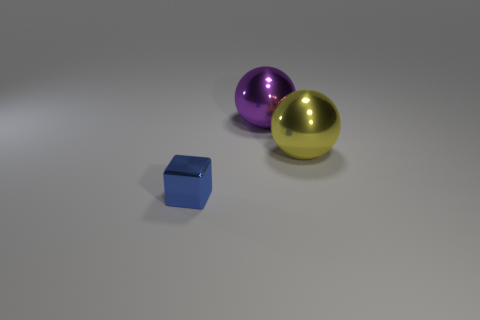Add 1 shiny cubes. How many objects exist? 4 Subtract all spheres. How many objects are left? 1 Subtract all purple balls. How many balls are left? 1 Subtract 2 balls. How many balls are left? 0 Subtract all purple cylinders. How many purple spheres are left? 1 Subtract all large metallic cylinders. Subtract all tiny blue blocks. How many objects are left? 2 Add 1 metal things. How many metal things are left? 4 Add 1 small red spheres. How many small red spheres exist? 1 Subtract 0 blue cylinders. How many objects are left? 3 Subtract all brown spheres. Subtract all cyan cylinders. How many spheres are left? 2 